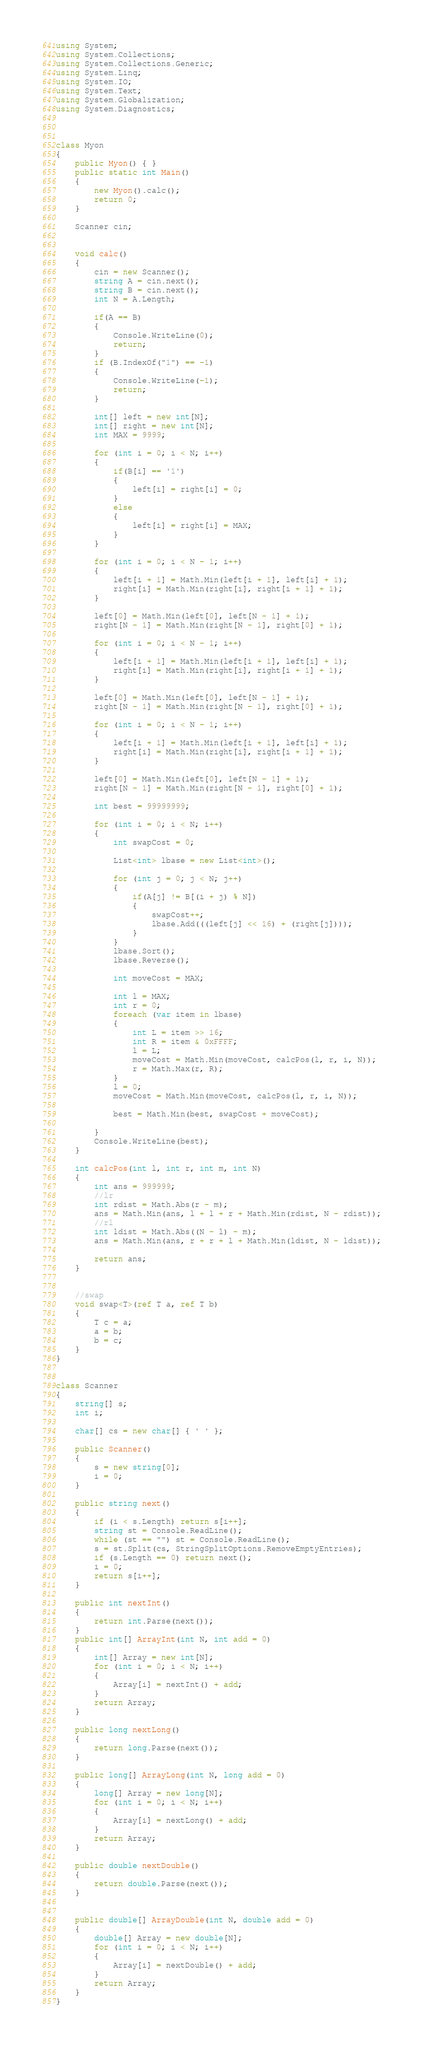<code> <loc_0><loc_0><loc_500><loc_500><_C#_>using System;
using System.Collections;
using System.Collections.Generic;
using System.Linq;
using System.IO;
using System.Text;
using System.Globalization;
using System.Diagnostics;



class Myon
{
    public Myon() { }
    public static int Main()
    {
        new Myon().calc();
        return 0;
    }

    Scanner cin;


    void calc()
    {
        cin = new Scanner();
        string A = cin.next();
        string B = cin.next();
        int N = A.Length;

        if(A == B)
        {
            Console.WriteLine(0);
            return;
        }
        if (B.IndexOf("1") == -1)
        {
            Console.WriteLine(-1);
            return;
        }

        int[] left = new int[N];
        int[] right = new int[N];
        int MAX = 9999;

        for (int i = 0; i < N; i++)
        {
            if(B[i] == '1')
            {
                left[i] = right[i] = 0;
            }
            else
            {
                left[i] = right[i] = MAX;
            }
        }

        for (int i = 0; i < N - 1; i++)
        {
            left[i + 1] = Math.Min(left[i + 1], left[i] + 1);
            right[i] = Math.Min(right[i], right[i + 1] + 1);
        }

        left[0] = Math.Min(left[0], left[N - 1] + 1);
        right[N - 1] = Math.Min(right[N - 1], right[0] + 1);

        for (int i = 0; i < N - 1; i++)
        {
            left[i + 1] = Math.Min(left[i + 1], left[i] + 1);
            right[i] = Math.Min(right[i], right[i + 1] + 1);
        }

        left[0] = Math.Min(left[0], left[N - 1] + 1);
        right[N - 1] = Math.Min(right[N - 1], right[0] + 1);

        for (int i = 0; i < N - 1; i++)
        {
            left[i + 1] = Math.Min(left[i + 1], left[i] + 1);
            right[i] = Math.Min(right[i], right[i + 1] + 1);
        }

        left[0] = Math.Min(left[0], left[N - 1] + 1);
        right[N - 1] = Math.Min(right[N - 1], right[0] + 1);

        int best = 99999999;

        for (int i = 0; i < N; i++)
        {
            int swapCost = 0;

            List<int> lbase = new List<int>();

            for (int j = 0; j < N; j++)
            {
                if(A[j] != B[(i + j) % N])
                {
                    swapCost++;
                    lbase.Add(((left[j] << 16) + (right[j])));
                }
            }
            lbase.Sort();
            lbase.Reverse();

            int moveCost = MAX;

            int l = MAX;
            int r = 0;
            foreach (var item in lbase)
            {
                int L = item >> 16;
                int R = item & 0xFFFF;
                l = L;
                moveCost = Math.Min(moveCost, calcPos(l, r, i, N));
                r = Math.Max(r, R);
            }
            l = 0;
            moveCost = Math.Min(moveCost, calcPos(l, r, i, N));

            best = Math.Min(best, swapCost + moveCost);

        }
        Console.WriteLine(best);
    }

    int calcPos(int l, int r, int m, int N)
    {
        int ans = 999999;
        //lr
        int rdist = Math.Abs(r - m);
        ans = Math.Min(ans, l + l + r + Math.Min(rdist, N - rdist));
        //rl
        int ldist = Math.Abs((N - l) - m);
        ans = Math.Min(ans, r + r + l + Math.Min(ldist, N - ldist));

        return ans;
    }


    //swap
    void swap<T>(ref T a, ref T b)
    {
        T c = a;
        a = b;
        b = c;
    }
}


class Scanner
{
    string[] s;
    int i;

    char[] cs = new char[] { ' ' };

    public Scanner()
    {
        s = new string[0];
        i = 0;
    }

    public string next()
    {
        if (i < s.Length) return s[i++];
        string st = Console.ReadLine();
        while (st == "") st = Console.ReadLine();
        s = st.Split(cs, StringSplitOptions.RemoveEmptyEntries);
        if (s.Length == 0) return next();
        i = 0;
        return s[i++];
    }

    public int nextInt()
    {
        return int.Parse(next());
    }
    public int[] ArrayInt(int N, int add = 0)
    {
        int[] Array = new int[N];
        for (int i = 0; i < N; i++)
        {
            Array[i] = nextInt() + add;
        }
        return Array;
    }

    public long nextLong()
    {
        return long.Parse(next());
    }

    public long[] ArrayLong(int N, long add = 0)
    {
        long[] Array = new long[N];
        for (int i = 0; i < N; i++)
        {
            Array[i] = nextLong() + add;
        }
        return Array;
    }

    public double nextDouble()
    {
        return double.Parse(next());
    }


    public double[] ArrayDouble(int N, double add = 0)
    {
        double[] Array = new double[N];
        for (int i = 0; i < N; i++)
        {
            Array[i] = nextDouble() + add;
        }
        return Array;
    }
}</code> 